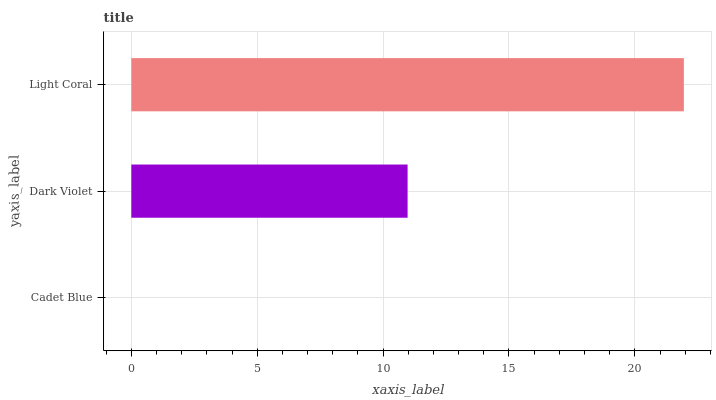Is Cadet Blue the minimum?
Answer yes or no. Yes. Is Light Coral the maximum?
Answer yes or no. Yes. Is Dark Violet the minimum?
Answer yes or no. No. Is Dark Violet the maximum?
Answer yes or no. No. Is Dark Violet greater than Cadet Blue?
Answer yes or no. Yes. Is Cadet Blue less than Dark Violet?
Answer yes or no. Yes. Is Cadet Blue greater than Dark Violet?
Answer yes or no. No. Is Dark Violet less than Cadet Blue?
Answer yes or no. No. Is Dark Violet the high median?
Answer yes or no. Yes. Is Dark Violet the low median?
Answer yes or no. Yes. Is Light Coral the high median?
Answer yes or no. No. Is Light Coral the low median?
Answer yes or no. No. 